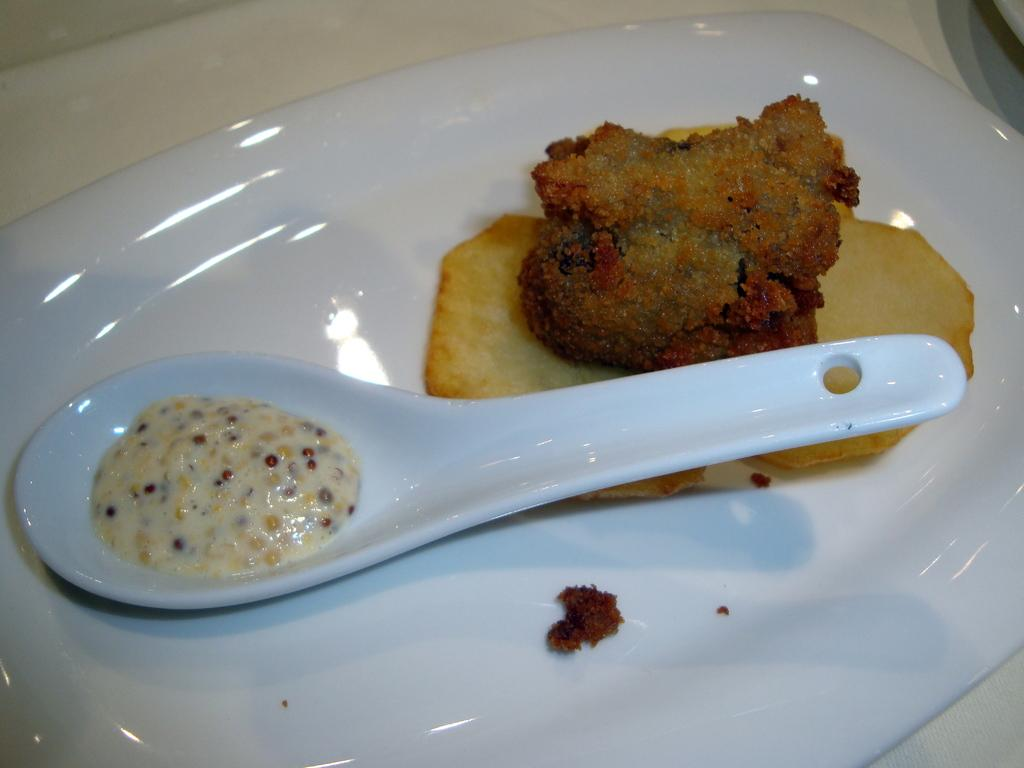What is present in the image related to food? There is food in the image. What utensil is visible in the image? There is a spoon with sauce in the image. Where is the spoon and sauce located? The spoon and sauce are in a plate. On what surface are the plate, spoon, and food placed? The plate, spoon, and food are placed on a table. What type of grip does the shoe have in the image? There is no shoe present in the image, so it is not possible to determine the type of grip it might have. 